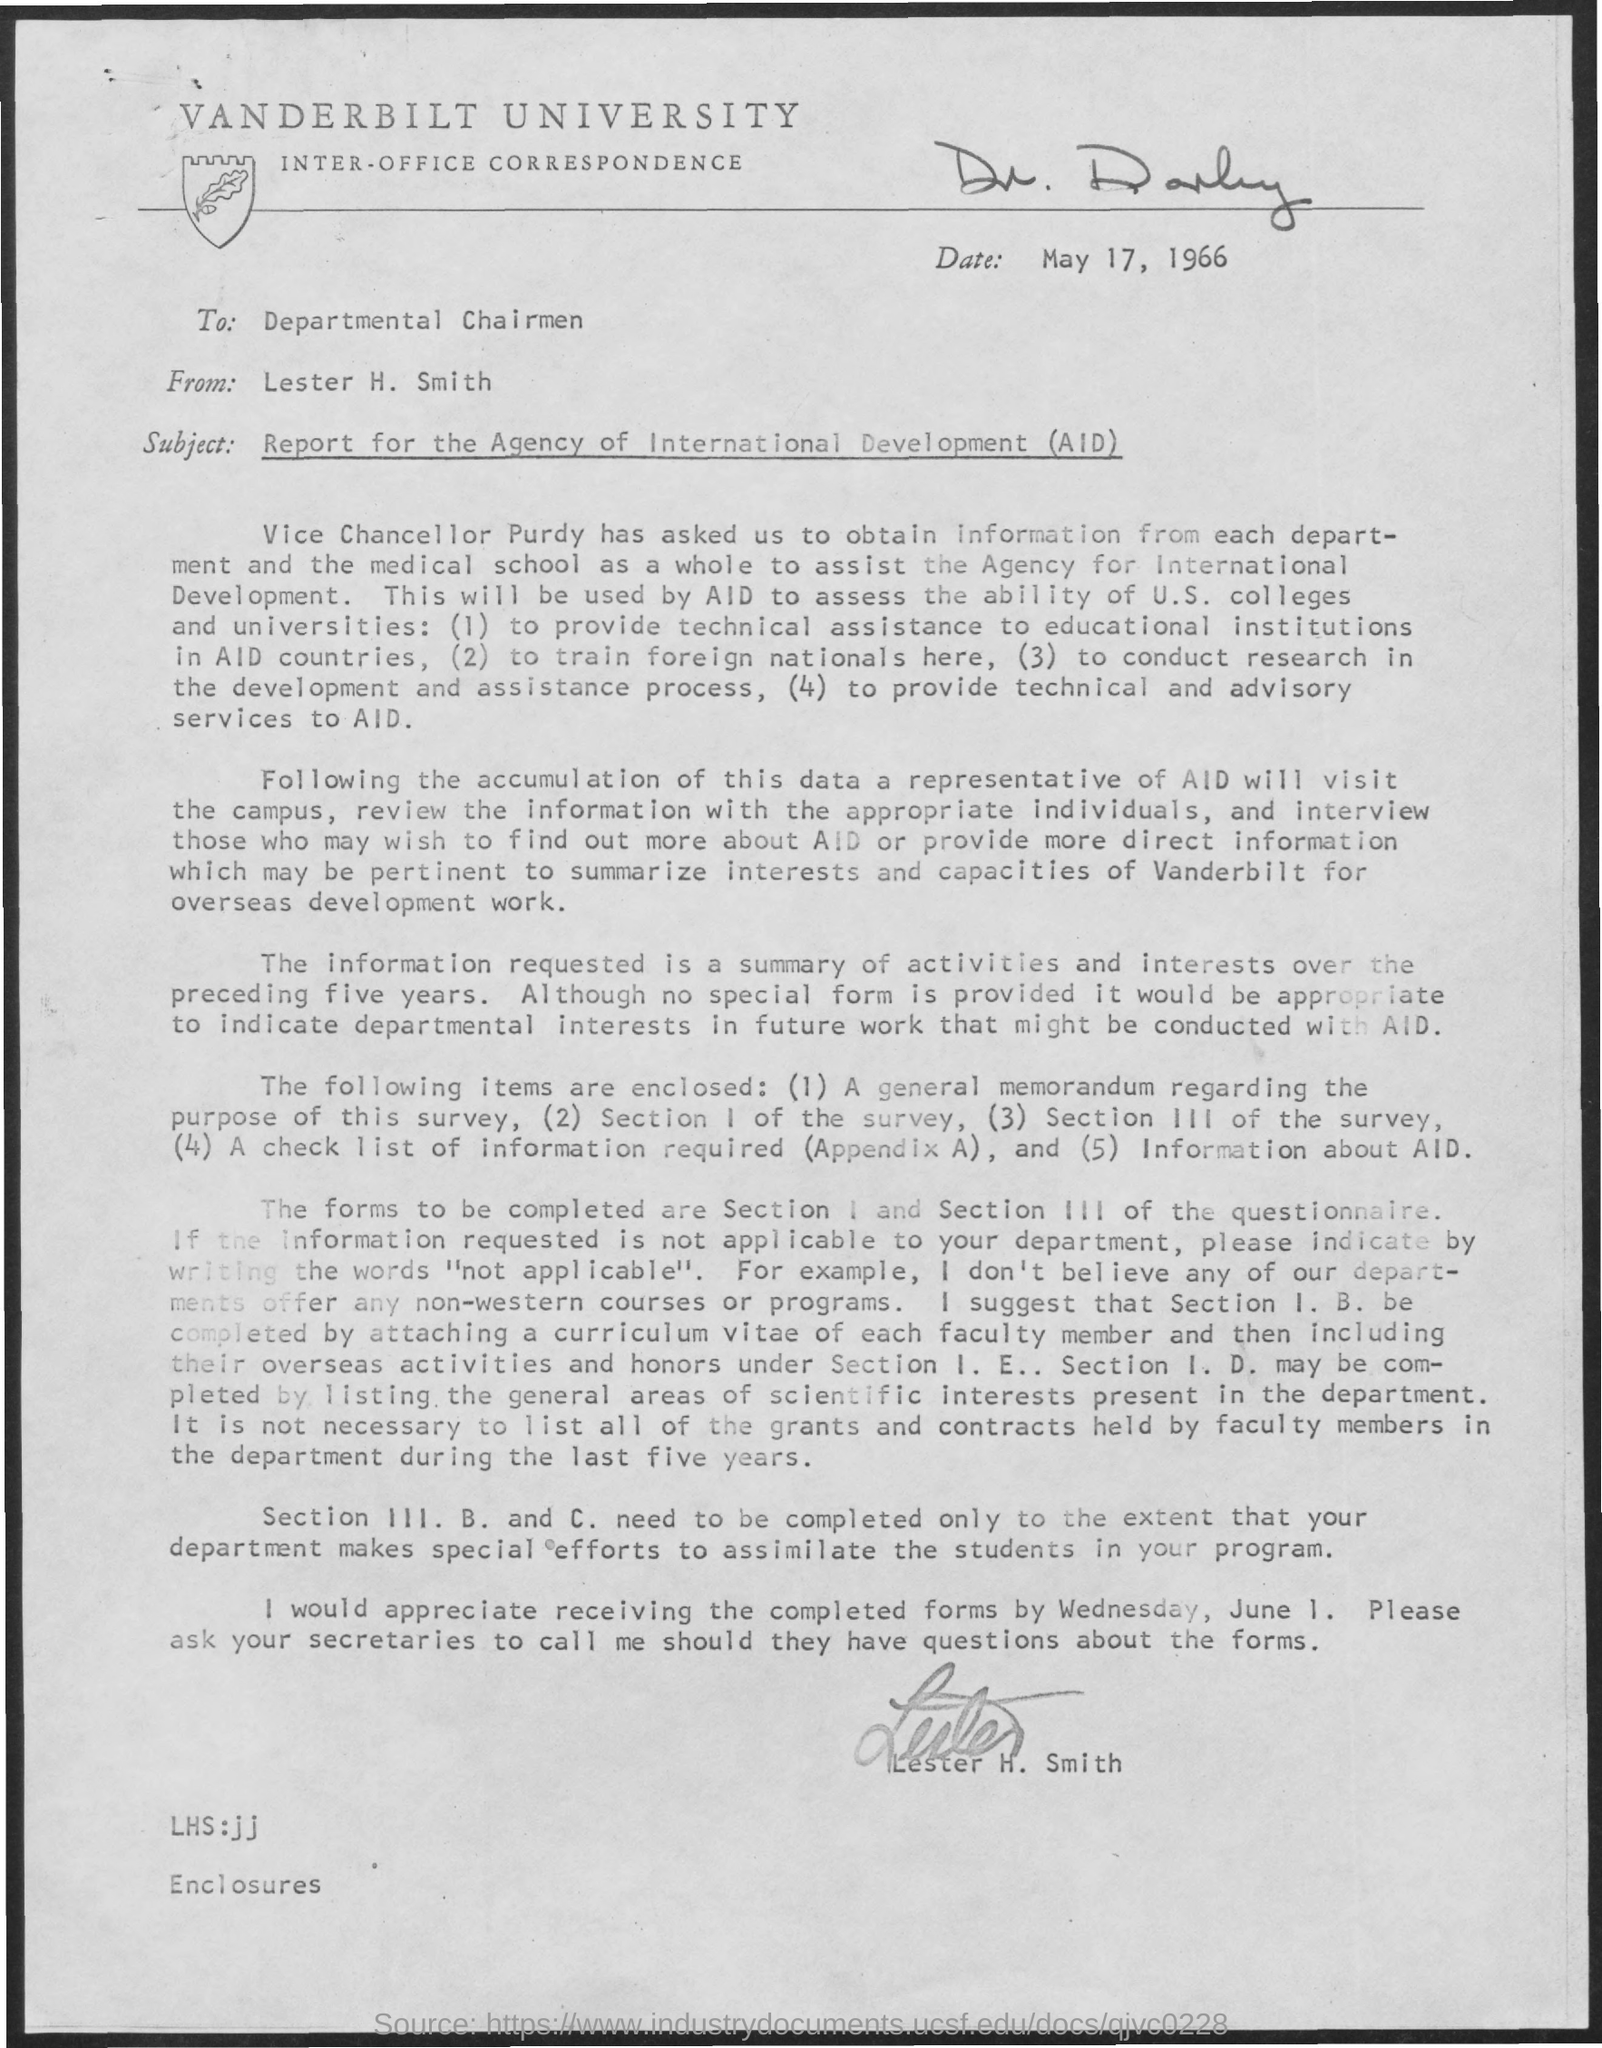Highlight a few significant elements in this photo. The letter is addressed to the departmental chairman. I would appreciate receiving the completed forms by Wednesday, June 1. Vanderbilt University is the name of a university. The letter is written by Lester H Smith. The date mentioned is May 17, 1966. 